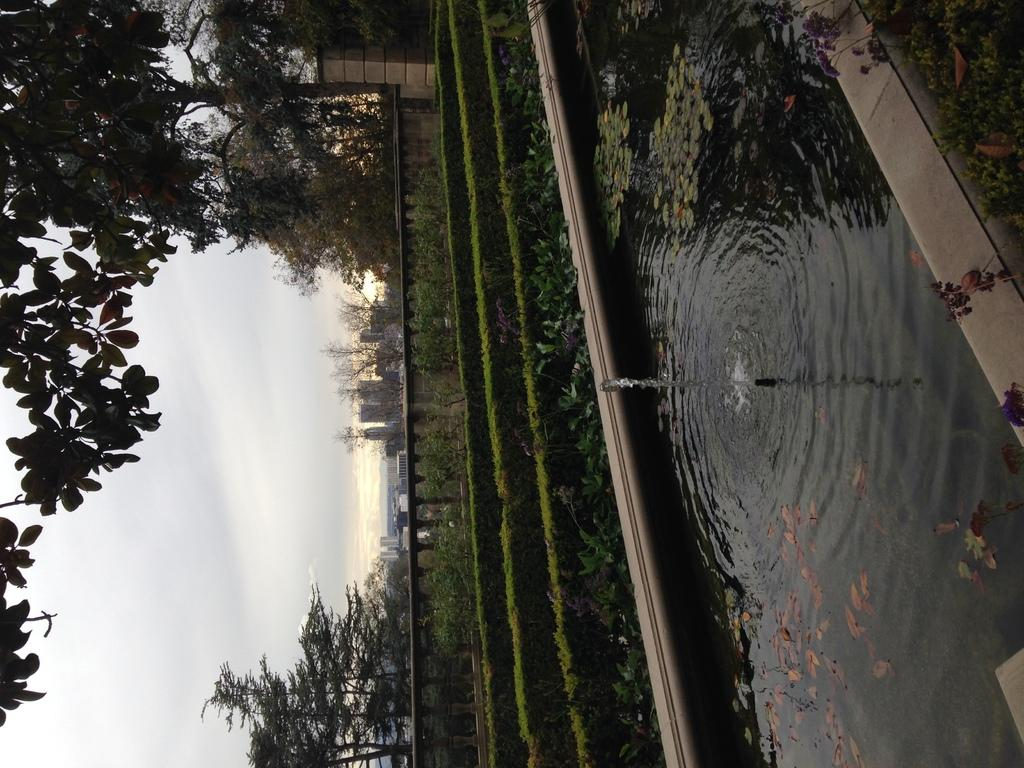What is the primary element visible in the image? There is water in the image. What type of vegetation can be seen in the image? There are plants and trees in the image. What type of structure is present in the image? There is a wall and a pillar in the image. What type of man-made structures are visible in the image? There are buildings in the image. What part of the natural environment is visible in the image? The sky is visible in the image. How does the beggar sort the punishment in the image? There is no beggar or punishment present in the image. 